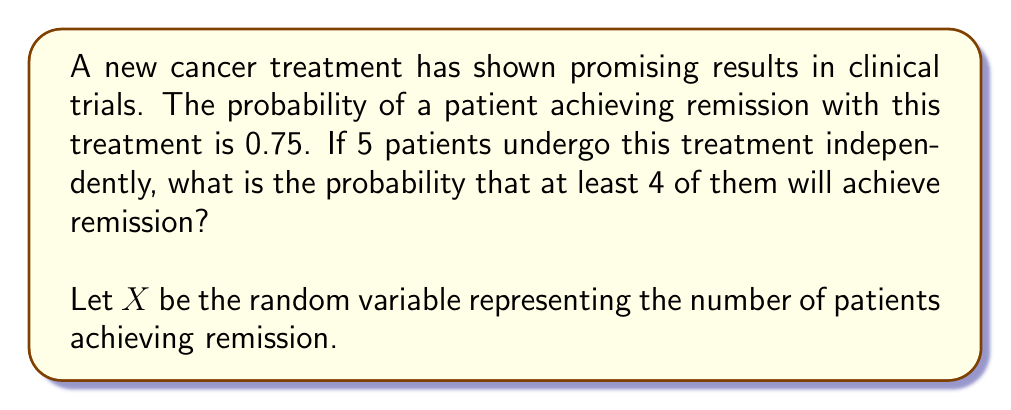Give your solution to this math problem. To solve this problem, we'll use the binomial distribution, as we have a fixed number of independent trials with two possible outcomes (remission or no remission).

Step 1: Identify the parameters of the binomial distribution
n = 5 (number of patients)
p = 0.75 (probability of remission for each patient)
X ~ Bin(5, 0.75)

Step 2: Calculate P(X ≥ 4)
We need to find P(X = 4) + P(X = 5)

Step 3: Use the binomial probability formula
$$P(X = k) = \binom{n}{k} p^k (1-p)^{n-k}$$

For X = 4:
$$P(X = 4) = \binom{5}{4} (0.75)^4 (0.25)^1 = 5 \cdot 0.75^4 \cdot 0.25 = 0.3955078125$$

For X = 5:
$$P(X = 5) = \binom{5}{5} (0.75)^5 (0.25)^0 = 1 \cdot 0.75^5 = 0.2373046875$$

Step 4: Sum the probabilities
P(X ≥ 4) = P(X = 4) + P(X = 5)
         = 0.3955078125 + 0.2373046875
         = 0.6328125

Therefore, the probability that at least 4 out of 5 patients will achieve remission is approximately 0.6328 or 63.28%.
Answer: 0.6328 